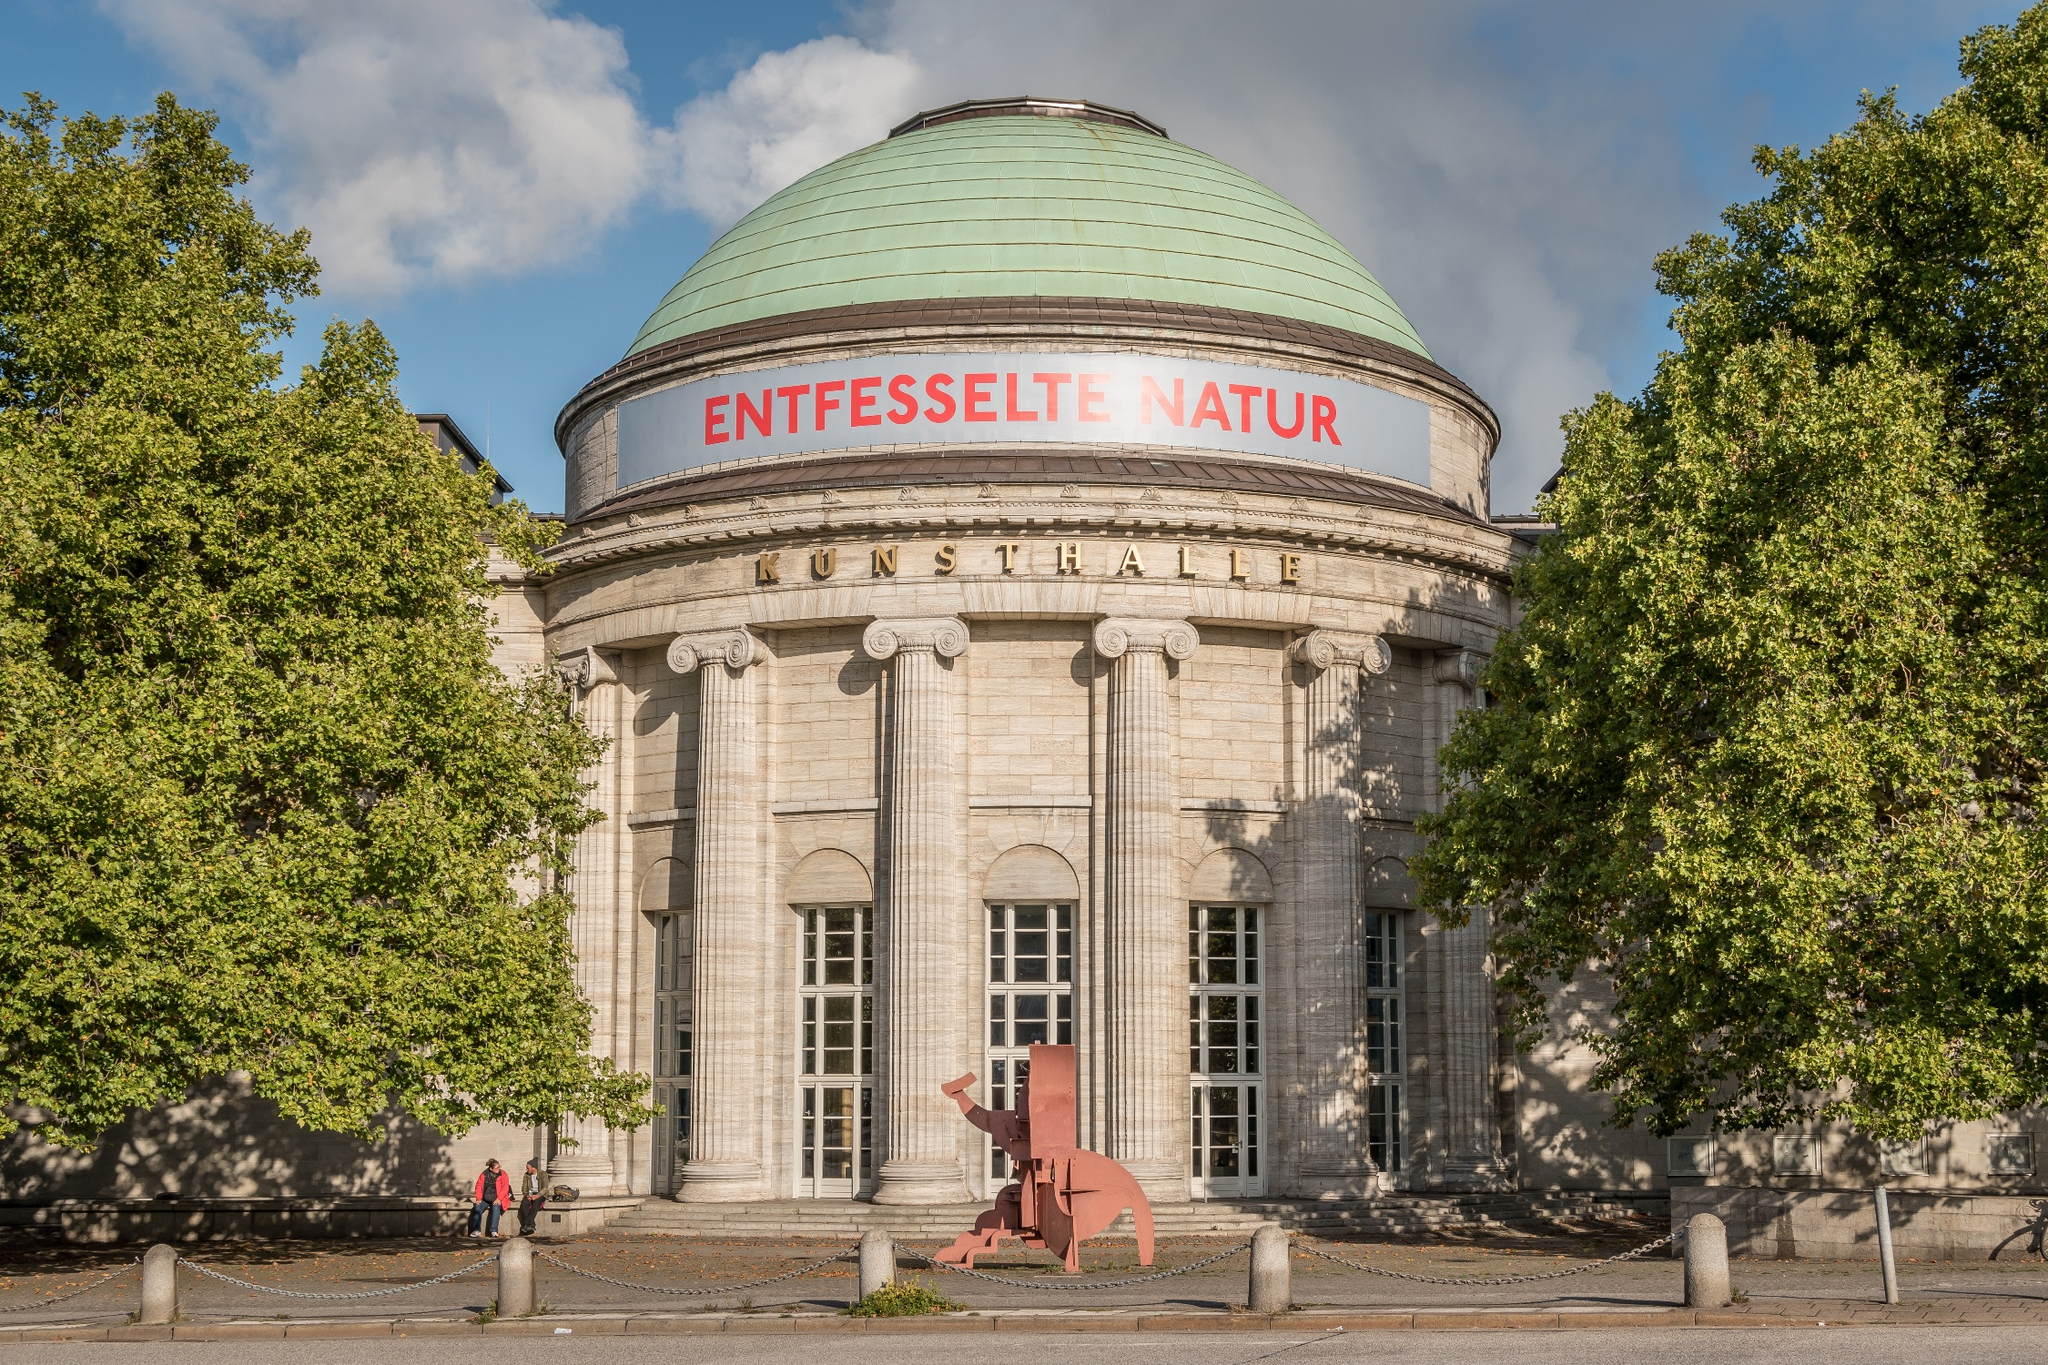What might a day at the Kunsthalle Hamburg be like for a visitor? A day at the Kunsthalle Hamburg promises to be an enriching experience for any visitor. As you approach the majestic museum, the grand neoclassical architecture and lush greenery set a serene and awe-inspiring tone. Entering through the impressive doorway, you're greeted by a vast array of exhibitions that span from classical masterpieces to avant-garde contemporary works. The 'Unleashed Nature' exhibition captivates with its vivid depictions of the wild and untamed aspects of the natural world. Interactive displays and installations ensure an engaging and immersive experience. Throughout the day, you might participate in a guided tour, offering deeper insights into the artworks and the stories behind them. A visit to the museum café provides a moment of reflection amidst art-themed décor. Before leaving, you browse the museum shop, finding unique souvenirs that capture the essence of your visit. The day concludes with a deeper appreciation for the boundless creativity and historical richness that Kunsthalle Hamburg embodies. Can you summarize this experience in one sentence? A day at the Kunsthalle Hamburg is an immersive journey through the realms of art, offering enriching insights and captivating experiences within a stunning neoclassical setting. 